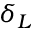<formula> <loc_0><loc_0><loc_500><loc_500>\delta _ { L }</formula> 